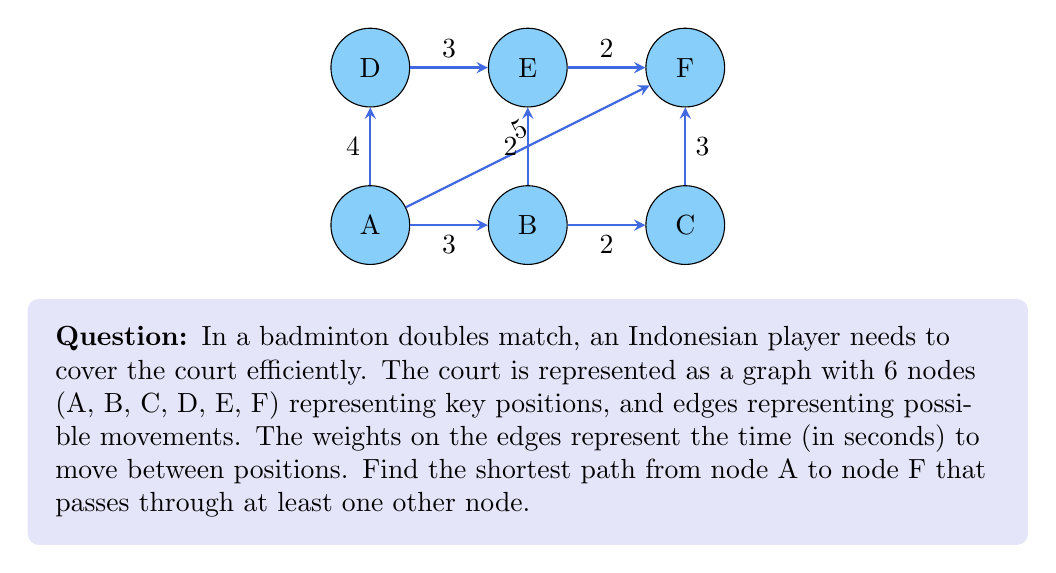What is the answer to this math problem? To solve this problem, we can use Dijkstra's algorithm to find the shortest path from A to F that passes through at least one other node. Let's follow these steps:

1) First, we need to list all possible paths from A to F that pass through at least one other node:
   
   A-B-F
   A-B-C-F
   A-B-E-F
   A-D-E-F

2) Now, let's calculate the total weight (time) for each path:

   A-B-F: 3 + 5 = 8 seconds
   A-B-C-F: 3 + 2 + 3 = 8 seconds
   A-B-E-F: 3 + 2 + 2 = 7 seconds
   A-D-E-F: 4 + 3 + 2 = 9 seconds

3) The path with the minimum total weight is A-B-E-F, with a total time of 7 seconds.

4) We can verify this is indeed the shortest path using Dijkstra's algorithm:

   Starting from A:
   A to B: 3 seconds
   A to D: 4 seconds
   A to F: 5 seconds (direct, not allowed as per question)

   From B:
   B to E: 2 seconds (total 5 seconds from A)
   B to C: 2 seconds (total 5 seconds from A)
   B to F: 5 seconds (total 8 seconds from A)

   From E:
   E to F: 2 seconds (total 7 seconds from A through B and E)

   This confirms that A-B-E-F is indeed the shortest path passing through at least one other node.

5) The path can be represented mathematically as:

   $$P = \{A, B, E, F\}$$

   With a total weight of:

   $$W = w_{AB} + w_{BE} + w_{EF} = 3 + 2 + 2 = 7$$

Therefore, the optimal path for the Indonesian badminton player's movement on the court from position A to F, passing through at least one other position, is A-B-E-F, taking 7 seconds.
Answer: A-B-E-F, 7 seconds 